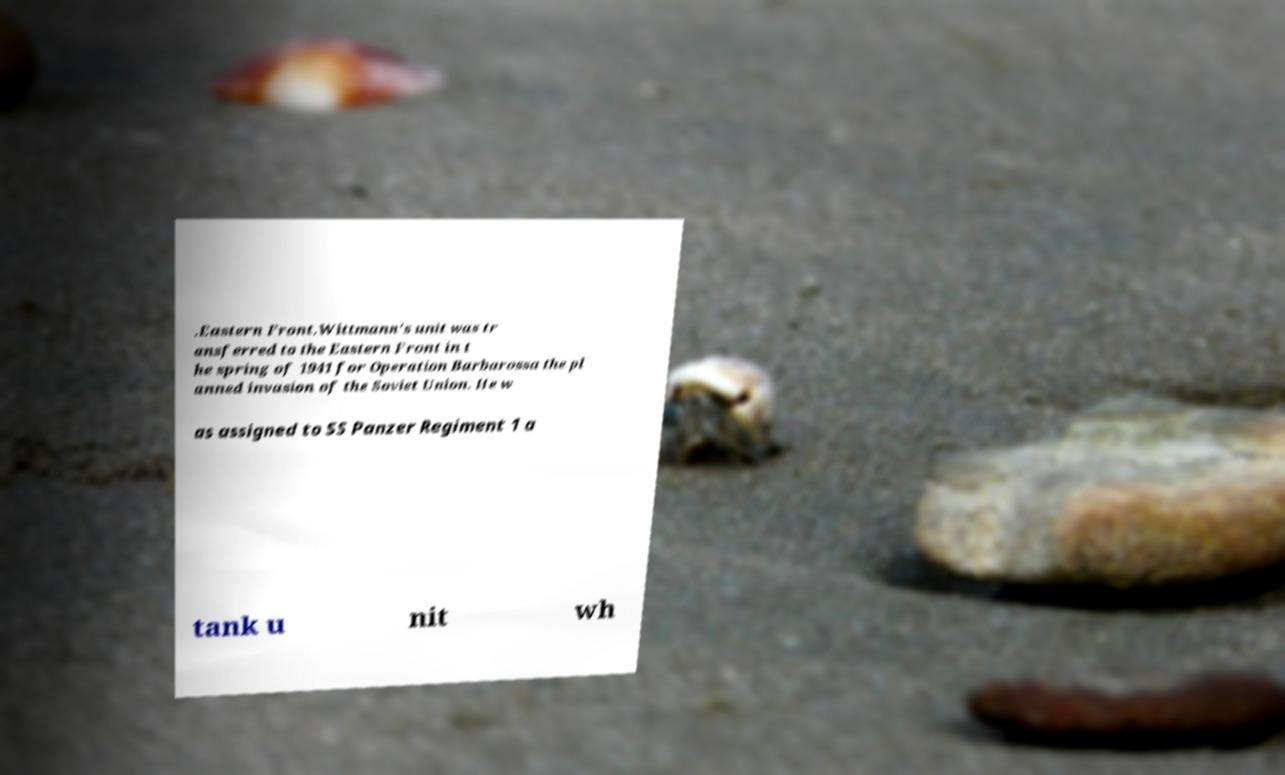Please read and relay the text visible in this image. What does it say? .Eastern Front.Wittmann's unit was tr ansferred to the Eastern Front in t he spring of 1941 for Operation Barbarossa the pl anned invasion of the Soviet Union. He w as assigned to SS Panzer Regiment 1 a tank u nit wh 